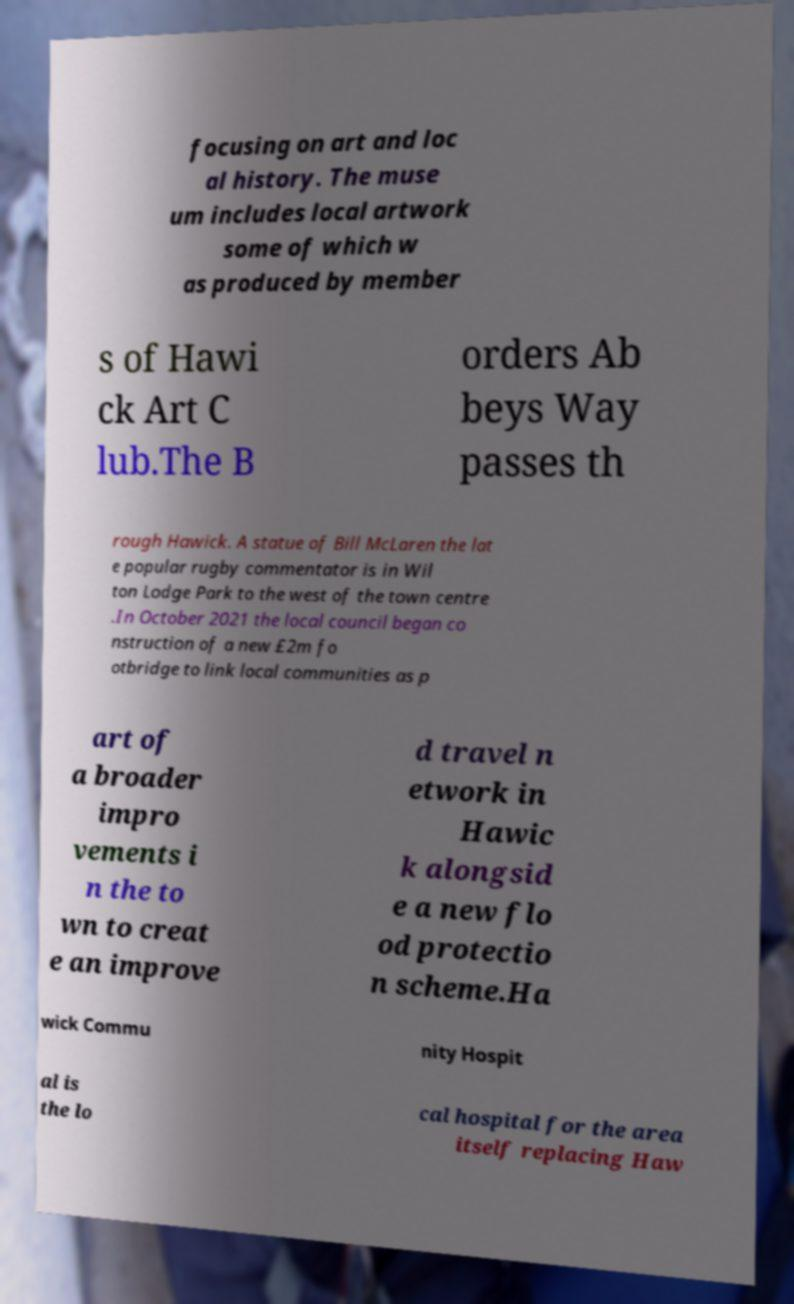For documentation purposes, I need the text within this image transcribed. Could you provide that? focusing on art and loc al history. The muse um includes local artwork some of which w as produced by member s of Hawi ck Art C lub.The B orders Ab beys Way passes th rough Hawick. A statue of Bill McLaren the lat e popular rugby commentator is in Wil ton Lodge Park to the west of the town centre .In October 2021 the local council began co nstruction of a new £2m fo otbridge to link local communities as p art of a broader impro vements i n the to wn to creat e an improve d travel n etwork in Hawic k alongsid e a new flo od protectio n scheme.Ha wick Commu nity Hospit al is the lo cal hospital for the area itself replacing Haw 